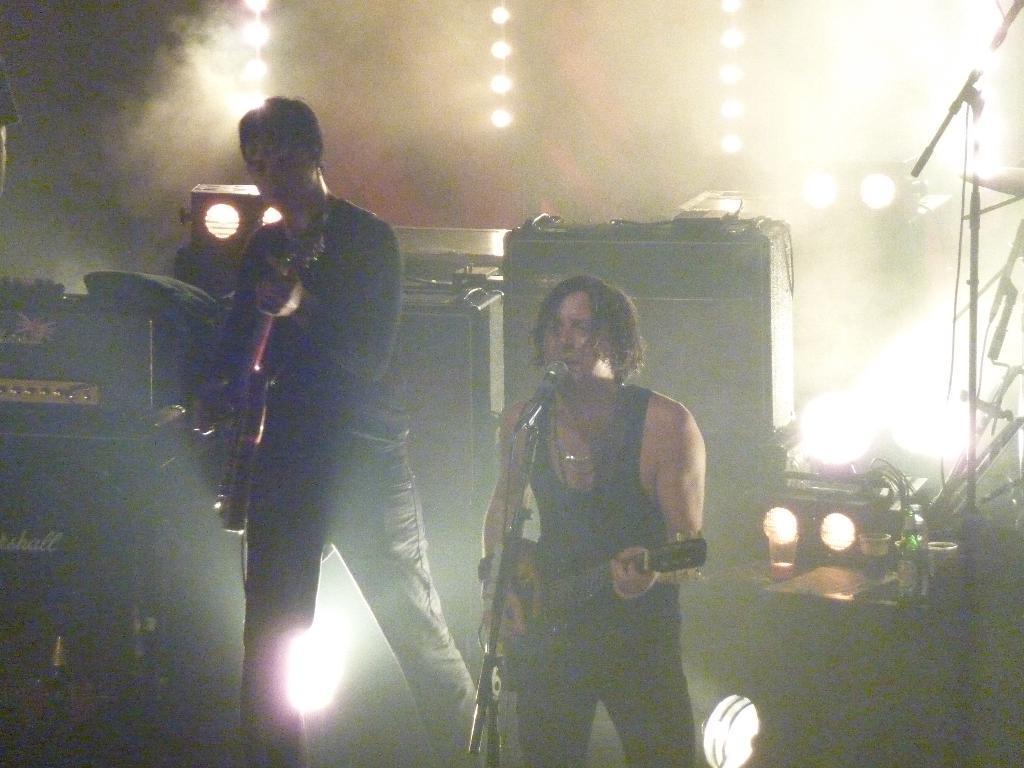Can you describe this image briefly? In this image we can see these two people are holding guitars in their hands and playing it and this person is singing through the mic which is in front of him. In the background, we can see speaker boxes, lights and glasses here also we can see smoke here. 